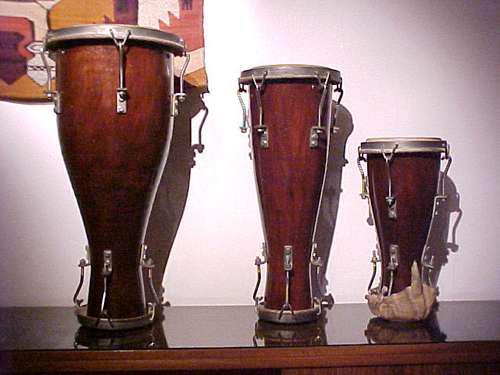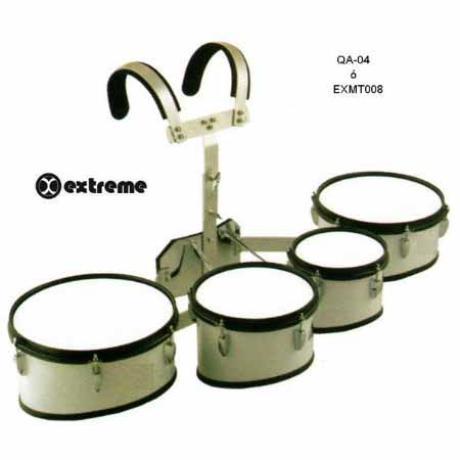The first image is the image on the left, the second image is the image on the right. For the images displayed, is the sentence "There are three bongo drums." factually correct? Answer yes or no. Yes. The first image is the image on the left, the second image is the image on the right. Assess this claim about the two images: "The left image shows three pedestal-shaped drums with wood-grain exteriors, and the right image shows at least three white drums with black rims.". Correct or not? Answer yes or no. Yes. 